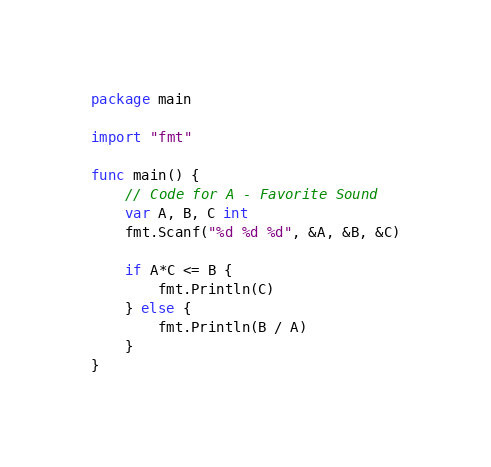Convert code to text. <code><loc_0><loc_0><loc_500><loc_500><_Go_>package main

import "fmt"

func main() {
	// Code for A - Favorite Sound
	var A, B, C int
	fmt.Scanf("%d %d %d", &A, &B, &C)

	if A*C <= B {
		fmt.Println(C)
	} else {
		fmt.Println(B / A)
	}
}
</code> 